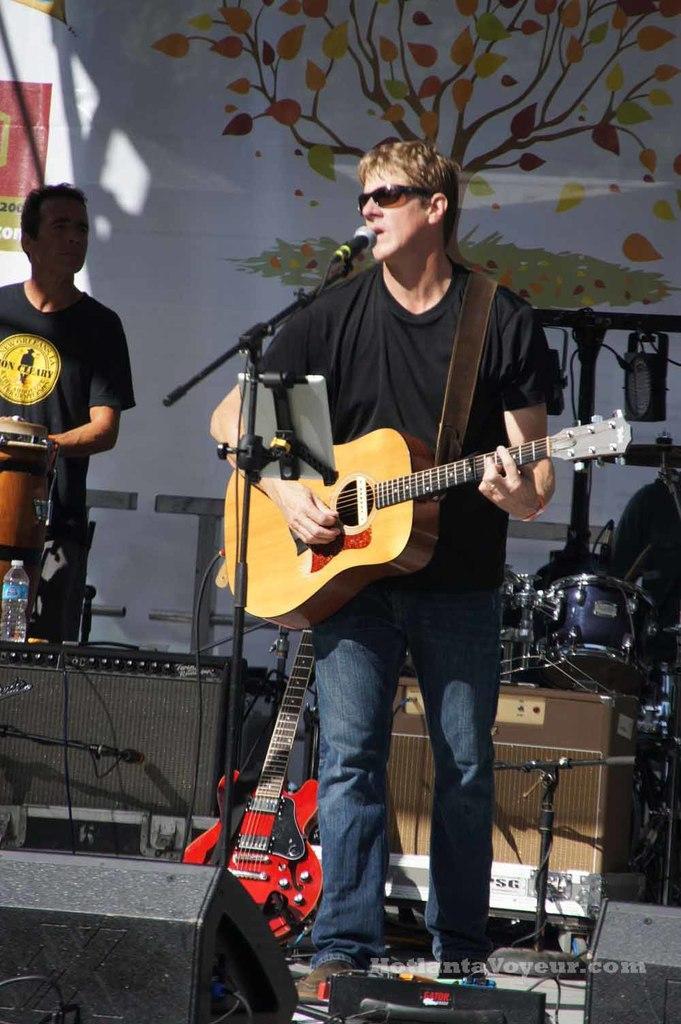How would you summarize this image in a sentence or two? Here in the middle we can see a person playing a guitar and singing a song with a microphone present in front of him and behind him we can see other people playing drums and there are water bottles present and guitars present and and there is a tree sticking on the wall 